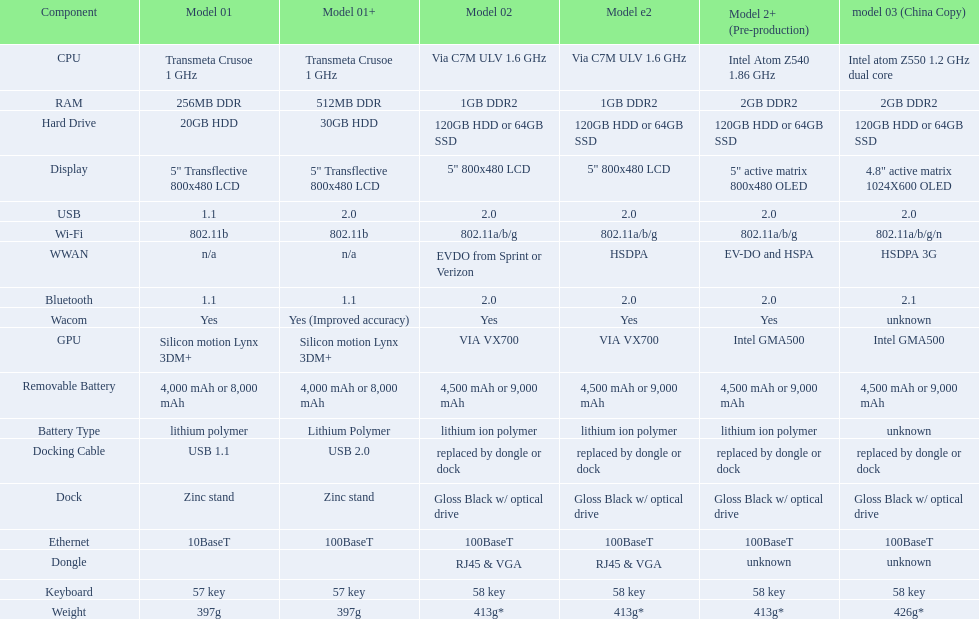Which element came before the usb? Display. 